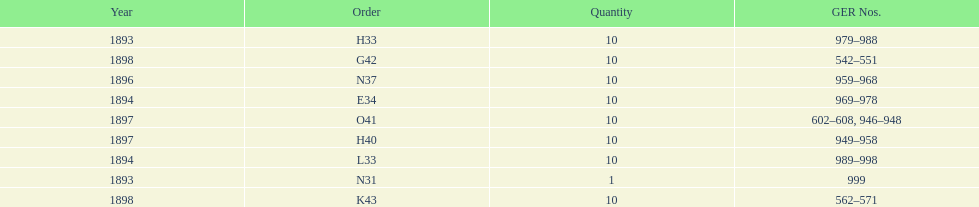Which year had the least ger numbers? 1893. 